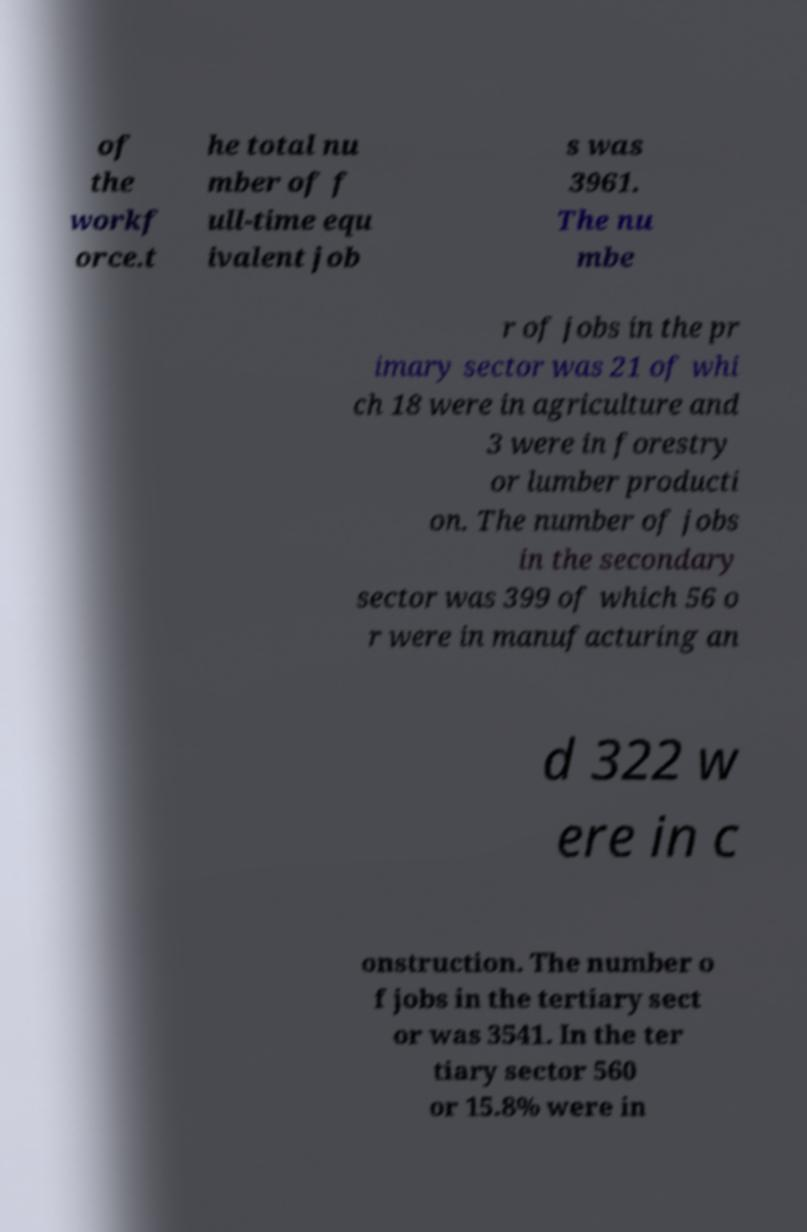What messages or text are displayed in this image? I need them in a readable, typed format. of the workf orce.t he total nu mber of f ull-time equ ivalent job s was 3961. The nu mbe r of jobs in the pr imary sector was 21 of whi ch 18 were in agriculture and 3 were in forestry or lumber producti on. The number of jobs in the secondary sector was 399 of which 56 o r were in manufacturing an d 322 w ere in c onstruction. The number o f jobs in the tertiary sect or was 3541. In the ter tiary sector 560 or 15.8% were in 